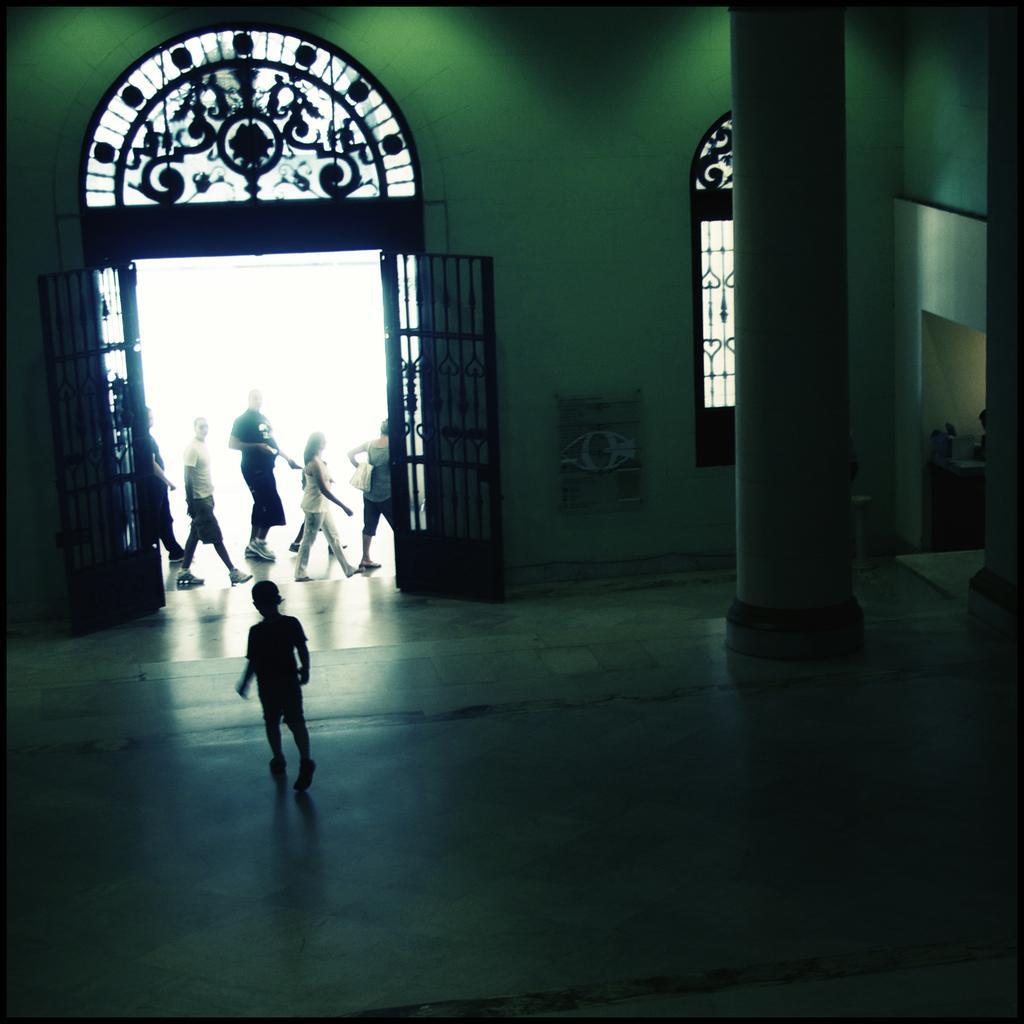How would you summarize this image in a sentence or two? At the bottom of the image there is a boy walking. On the right there is a pillar. In the background there is a wall and a door. We can see people walking and there is a window. 